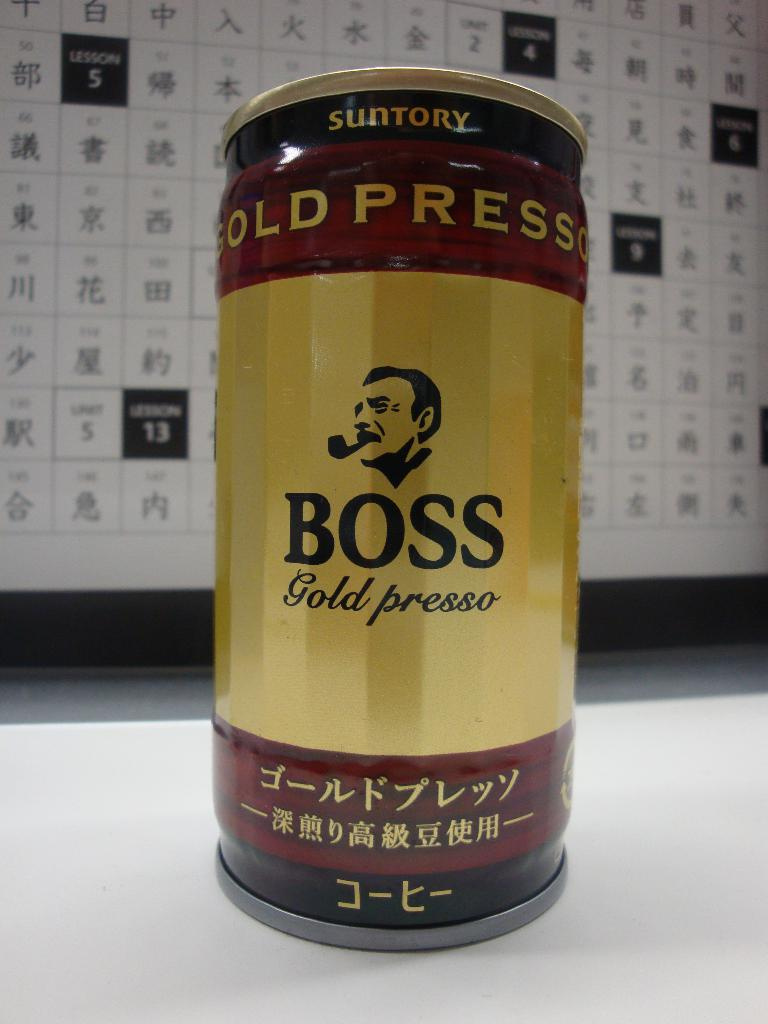Can you explain what the Japanese text might suggest about the branding or contents of this product? The Japanese text in the background likely offers details about the coffee blend or the branding story of BOSS Gold Presso. Generally, such texts convey premium quality or specific blend characteristics, aligning with the sophisticated image of a 'boss.' 